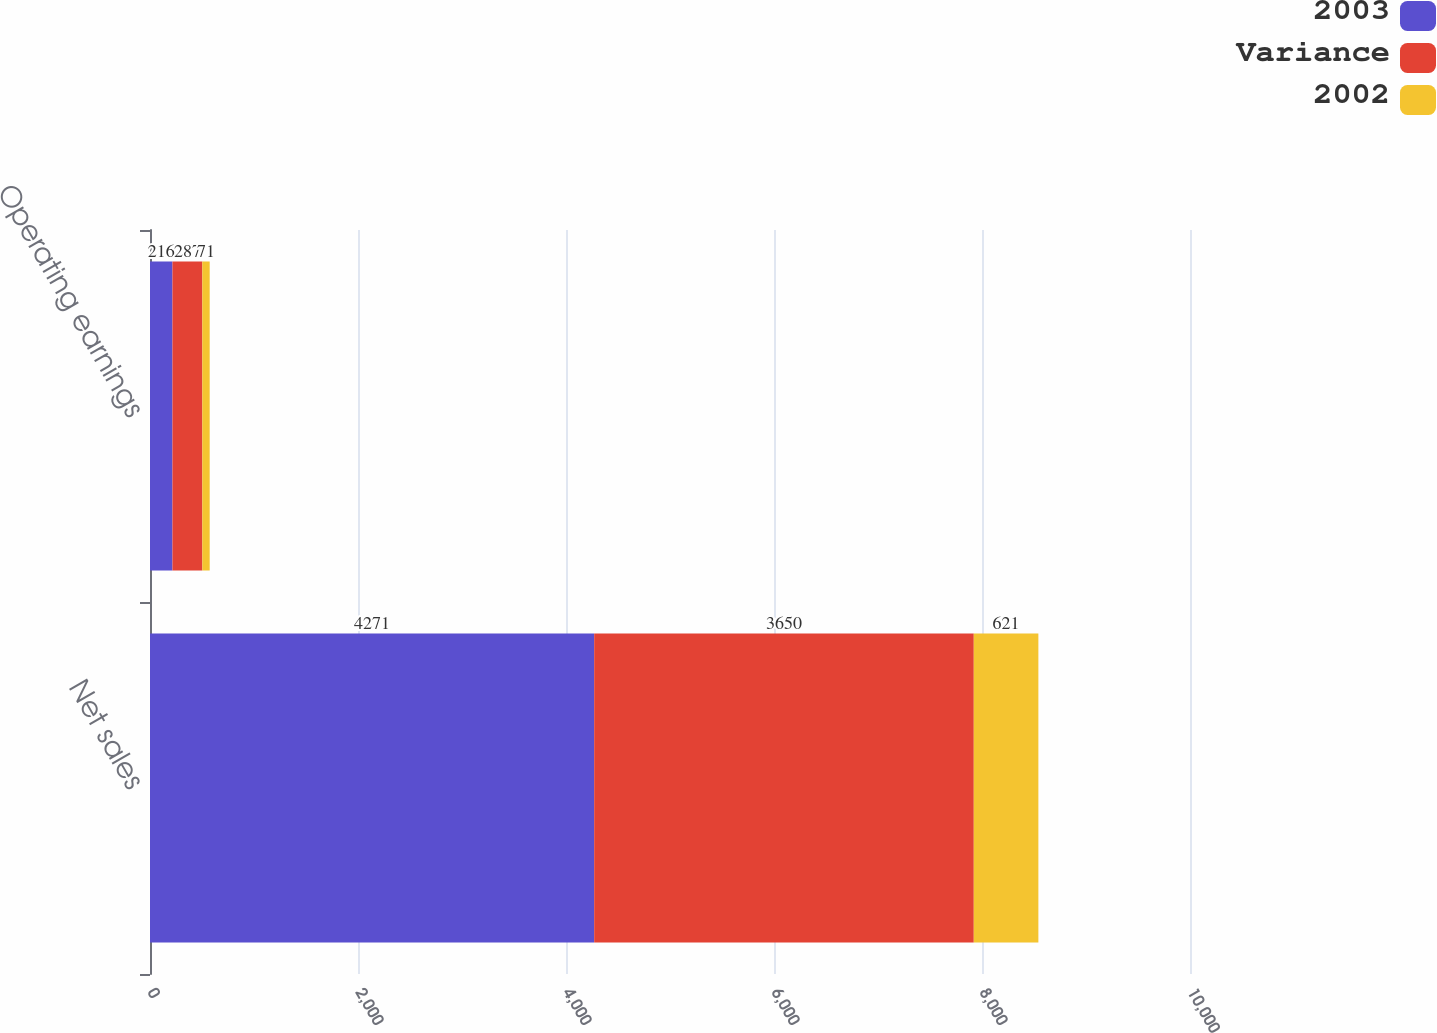Convert chart to OTSL. <chart><loc_0><loc_0><loc_500><loc_500><stacked_bar_chart><ecel><fcel>Net sales<fcel>Operating earnings<nl><fcel>2003<fcel>4271<fcel>216<nl><fcel>Variance<fcel>3650<fcel>287<nl><fcel>2002<fcel>621<fcel>71<nl></chart> 